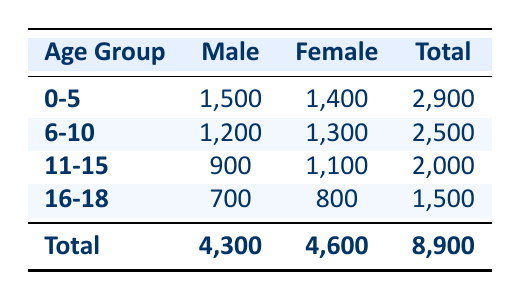What is the referral count for females in the age group 6-10? The table shows that for the age group 6-10, the referral count for females is listed directly as 1,300.
Answer: 1,300 What is the total number of referrals for the age group 11-15? In the table, the total referrals for the age group 11-15 are provided as 2,000.
Answer: 2,000 Are there more referrals for males or females in the age group 0-5? For the age group 0-5, males have 1,500 referrals and females have 1,400 referrals. Since 1,500 is greater than 1,400, there are more referrals for males.
Answer: Yes What is the combined referral count for all age groups for males? The referral counts for males are 1,500 (0-5) + 1,200 (6-10) + 900 (11-15) + 700 (16-18) = 4,300. Thus, the combined total is 4,300.
Answer: 4,300 Is the total referral count for females across all age groups greater than that for males? The total referral count for females is 1,400 (0-5) + 1,300 (6-10) + 1,100 (11-15) + 800 (16-18) = 4,600. The total for males is 4,300. Since 4,600 is greater than 4,300, the fact is true.
Answer: Yes What is the average referral count for the age group 16-18? The referral counts for the age group 16-18 are 700 (male) and 800 (female). The average is calculated as (700 + 800) / 2 = 750.
Answer: 750 What percentage of the total referrals does the age group 11-15 represent? The total referrals are 8,900. The count for 11-15 is 2,000. The percentage is (2,000 / 8,900) * 100 = approximately 22.5%.
Answer: 22.5% How many more referrals for females are there compared to males in the age group 16-18? In the age group 16-18, the referrals for females are 800 and for males are 700. The difference is 800 - 700 = 100.
Answer: 100 In which age group is the referral count for females the highest? The table shows the female referral counts for each age group: 1,400 (0-5), 1,300 (6-10), 1,100 (11-15), and 800 (16-18). The highest count is 1,400 in the 0-5 age group.
Answer: 0-5 